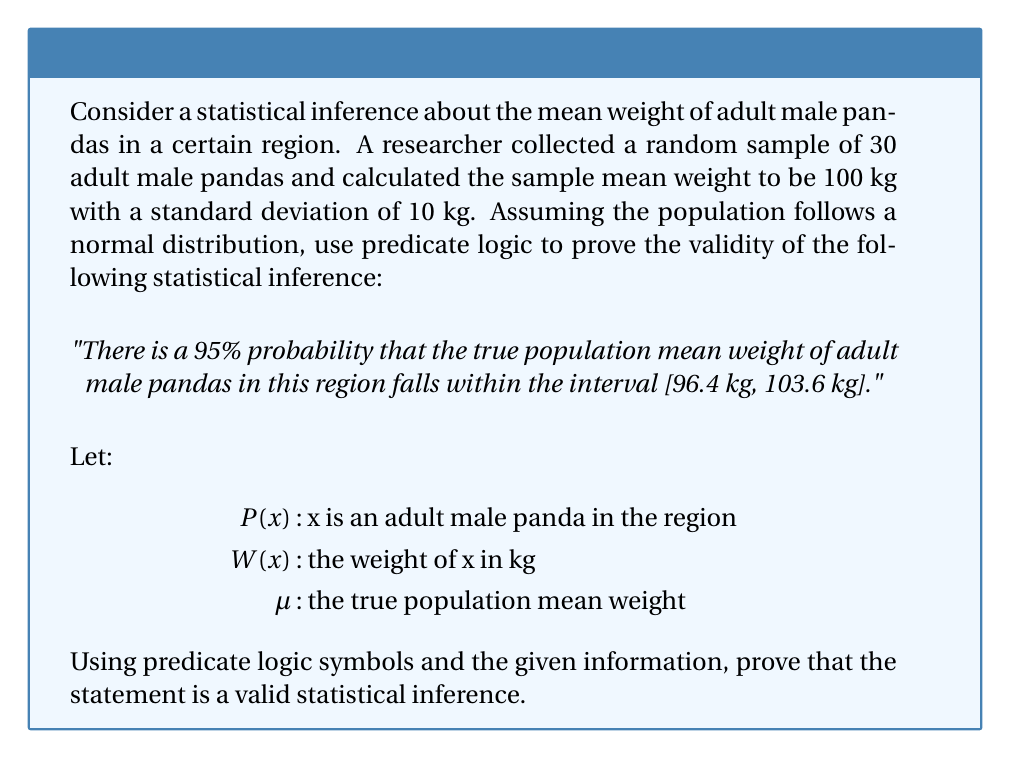Help me with this question. To prove the validity of this statistical inference using predicate logic, we'll follow these steps:

1. Define the sample mean and standard error:
   Sample mean: $\bar{x} = 100$ kg
   Sample standard deviation: $s = 10$ kg
   Sample size: $n = 30$
   Standard error: $SE = \frac{s}{\sqrt{n}} = \frac{10}{\sqrt{30}} \approx 1.83$ kg

2. For a 95% confidence interval, we use the z-score of 1.96 (rounded to 2 decimal places).

3. The confidence interval is calculated as:
   $CI = \bar{x} \pm z \cdot SE = 100 \pm 1.96 \cdot 1.83 = [96.4, 103.6]$ kg

4. Now, let's express this using predicate logic:

   $\forall x (P(x) \rightarrow W(x))$ : For all x, if x is an adult male panda in the region, then W(x) is its weight.

   $\mu = E[W(x)|P(x)]$ : The population mean μ is the expected value of W(x) given P(x).

   $P(96.4 \leq \mu \leq 103.6) = 0.95$ : The probability that μ falls within the interval [96.4, 103.6] is 0.95.

5. The validity of this inference comes from the Central Limit Theorem and the properties of normal distributions:

   $\frac{\bar{x} - \mu}{SE} \sim N(0,1)$ : The standardized sample mean follows a standard normal distribution.

   $P(-1.96 \leq \frac{\bar{x} - \mu}{SE} \leq 1.96) = 0.95$ : There's a 95% probability that the standardized sample mean falls within ±1.96 standard deviations.

6. Rearranging the inequality:
   $P(\bar{x} - 1.96 \cdot SE \leq \mu \leq \bar{x} + 1.96 \cdot SE) = 0.95$

7. Substituting the values:
   $P(100 - 1.96 \cdot 1.83 \leq \mu \leq 100 + 1.96 \cdot 1.83) = 0.95$
   $P(96.4 \leq \mu \leq 103.6) = 0.95$

This proves that the statistical inference is valid based on the given sample data and the assumptions of normality and random sampling.
Answer: The inference is valid because $P(96.4 \leq \mu \leq 103.6) = 0.95$, where $\mu = E[W(x)|P(x)]$, derived from the Central Limit Theorem and properties of normal distributions. 